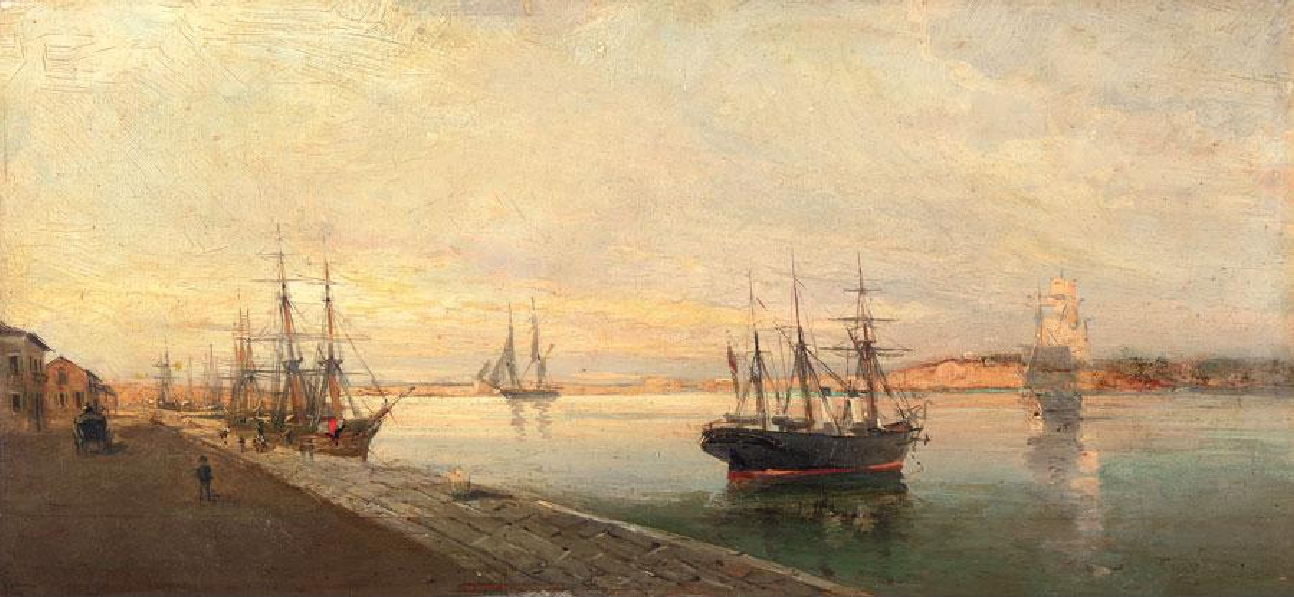Describe the use of light in this painting. In this painting, light plays a crucial role in setting the overall tone and mood. The artist utilizes a soft, diffused light, likely representing either sunrise or sunset, to bathe the scene in a warm glow. This use of light enhances the impressionist style by emphasizing the play of light on surfaces and the subtle shifts in color and shadow. The warm, golden hues of the light create a soothing and inviting atmosphere, drawing the viewer's eye across the canvas and highlighting the various elements of the harbor. 